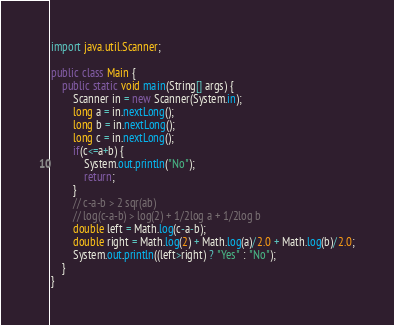<code> <loc_0><loc_0><loc_500><loc_500><_Java_>import java.util.Scanner;

public class Main {
    public static void main(String[] args) {
        Scanner in = new Scanner(System.in);
        long a = in.nextLong();
        long b = in.nextLong();
        long c = in.nextLong();
        if(c<=a+b) {
            System.out.println("No");
            return;
        }
        // c-a-b > 2 sqr(ab)
        // log(c-a-b) > log(2) + 1/2log a + 1/2log b
        double left = Math.log(c-a-b);
        double right = Math.log(2) + Math.log(a)/2.0 + Math.log(b)/2.0;
        System.out.println((left>right) ? "Yes" : "No");
    }
}
</code> 